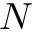<formula> <loc_0><loc_0><loc_500><loc_500>N</formula> 